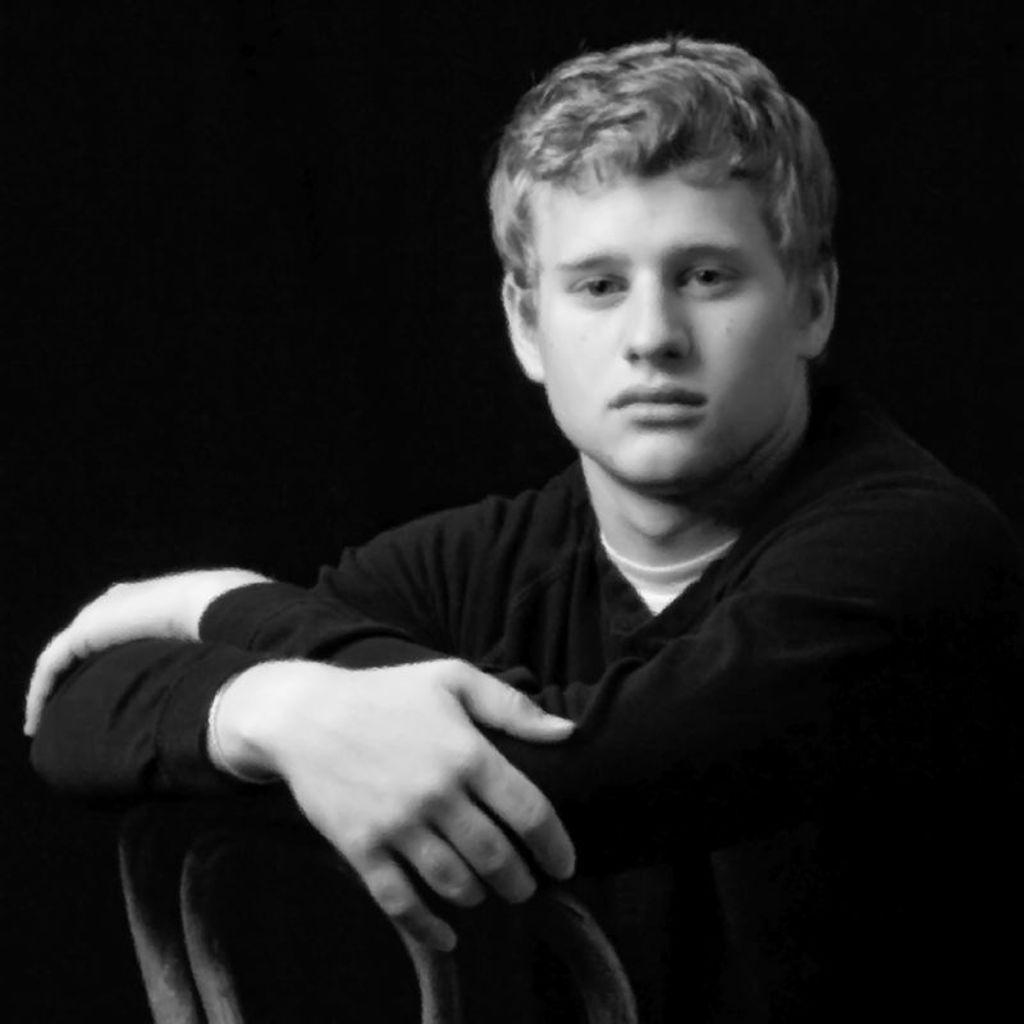Could you give a brief overview of what you see in this image? In this image we can see a person wearing black dress and the background is too dark. 